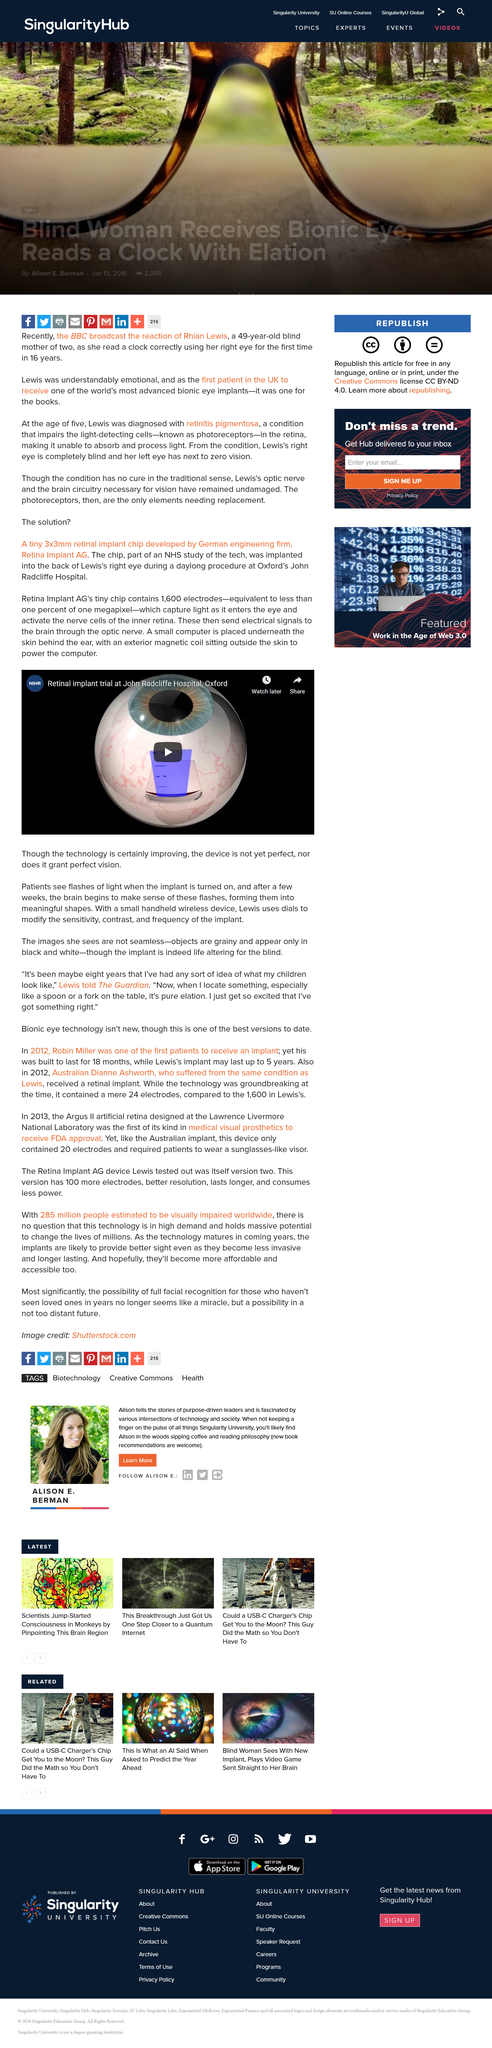Give some essential details in this illustration. The retinal implant video is available on the NIHR channel. The retinal implant chip is a device with a size of 3x3 millimeters. The Retinal Implant chip contains 1,600 electrodes. 